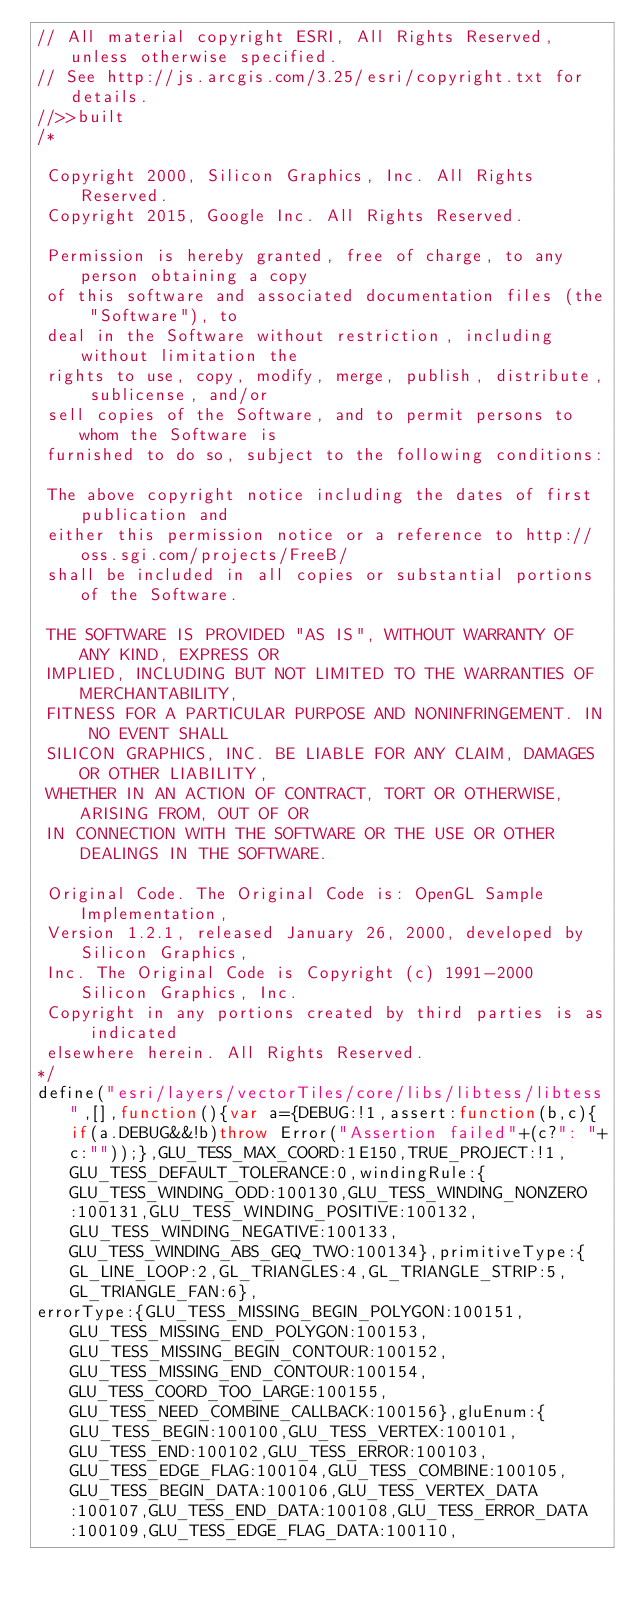Convert code to text. <code><loc_0><loc_0><loc_500><loc_500><_JavaScript_>// All material copyright ESRI, All Rights Reserved, unless otherwise specified.
// See http://js.arcgis.com/3.25/esri/copyright.txt for details.
//>>built
/*

 Copyright 2000, Silicon Graphics, Inc. All Rights Reserved.
 Copyright 2015, Google Inc. All Rights Reserved.

 Permission is hereby granted, free of charge, to any person obtaining a copy
 of this software and associated documentation files (the "Software"), to
 deal in the Software without restriction, including without limitation the
 rights to use, copy, modify, merge, publish, distribute, sublicense, and/or
 sell copies of the Software, and to permit persons to whom the Software is
 furnished to do so, subject to the following conditions:

 The above copyright notice including the dates of first publication and
 either this permission notice or a reference to http://oss.sgi.com/projects/FreeB/
 shall be included in all copies or substantial portions of the Software.

 THE SOFTWARE IS PROVIDED "AS IS", WITHOUT WARRANTY OF ANY KIND, EXPRESS OR
 IMPLIED, INCLUDING BUT NOT LIMITED TO THE WARRANTIES OF MERCHANTABILITY,
 FITNESS FOR A PARTICULAR PURPOSE AND NONINFRINGEMENT. IN NO EVENT SHALL
 SILICON GRAPHICS, INC. BE LIABLE FOR ANY CLAIM, DAMAGES OR OTHER LIABILITY,
 WHETHER IN AN ACTION OF CONTRACT, TORT OR OTHERWISE, ARISING FROM, OUT OF OR
 IN CONNECTION WITH THE SOFTWARE OR THE USE OR OTHER DEALINGS IN THE SOFTWARE.

 Original Code. The Original Code is: OpenGL Sample Implementation,
 Version 1.2.1, released January 26, 2000, developed by Silicon Graphics,
 Inc. The Original Code is Copyright (c) 1991-2000 Silicon Graphics, Inc.
 Copyright in any portions created by third parties is as indicated
 elsewhere herein. All Rights Reserved.
*/
define("esri/layers/vectorTiles/core/libs/libtess/libtess",[],function(){var a={DEBUG:!1,assert:function(b,c){if(a.DEBUG&&!b)throw Error("Assertion failed"+(c?": "+c:""));},GLU_TESS_MAX_COORD:1E150,TRUE_PROJECT:!1,GLU_TESS_DEFAULT_TOLERANCE:0,windingRule:{GLU_TESS_WINDING_ODD:100130,GLU_TESS_WINDING_NONZERO:100131,GLU_TESS_WINDING_POSITIVE:100132,GLU_TESS_WINDING_NEGATIVE:100133,GLU_TESS_WINDING_ABS_GEQ_TWO:100134},primitiveType:{GL_LINE_LOOP:2,GL_TRIANGLES:4,GL_TRIANGLE_STRIP:5,GL_TRIANGLE_FAN:6},
errorType:{GLU_TESS_MISSING_BEGIN_POLYGON:100151,GLU_TESS_MISSING_END_POLYGON:100153,GLU_TESS_MISSING_BEGIN_CONTOUR:100152,GLU_TESS_MISSING_END_CONTOUR:100154,GLU_TESS_COORD_TOO_LARGE:100155,GLU_TESS_NEED_COMBINE_CALLBACK:100156},gluEnum:{GLU_TESS_BEGIN:100100,GLU_TESS_VERTEX:100101,GLU_TESS_END:100102,GLU_TESS_ERROR:100103,GLU_TESS_EDGE_FLAG:100104,GLU_TESS_COMBINE:100105,GLU_TESS_BEGIN_DATA:100106,GLU_TESS_VERTEX_DATA:100107,GLU_TESS_END_DATA:100108,GLU_TESS_ERROR_DATA:100109,GLU_TESS_EDGE_FLAG_DATA:100110,</code> 